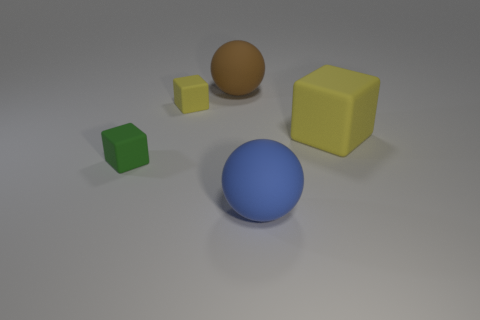Subtract all green cubes. How many cubes are left? 2 Subtract all green blocks. How many blocks are left? 2 Subtract 1 blue balls. How many objects are left? 4 Subtract all spheres. How many objects are left? 3 Subtract 1 blocks. How many blocks are left? 2 Subtract all blue spheres. Subtract all green cubes. How many spheres are left? 1 Subtract all gray cubes. How many gray spheres are left? 0 Subtract all tiny cubes. Subtract all large yellow matte things. How many objects are left? 2 Add 1 small green matte blocks. How many small green matte blocks are left? 2 Add 2 matte balls. How many matte balls exist? 4 